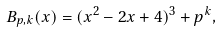Convert formula to latex. <formula><loc_0><loc_0><loc_500><loc_500>B _ { p , k } ( x ) = ( x ^ { 2 } - 2 x + 4 ) ^ { 3 } + p ^ { k } ,</formula> 